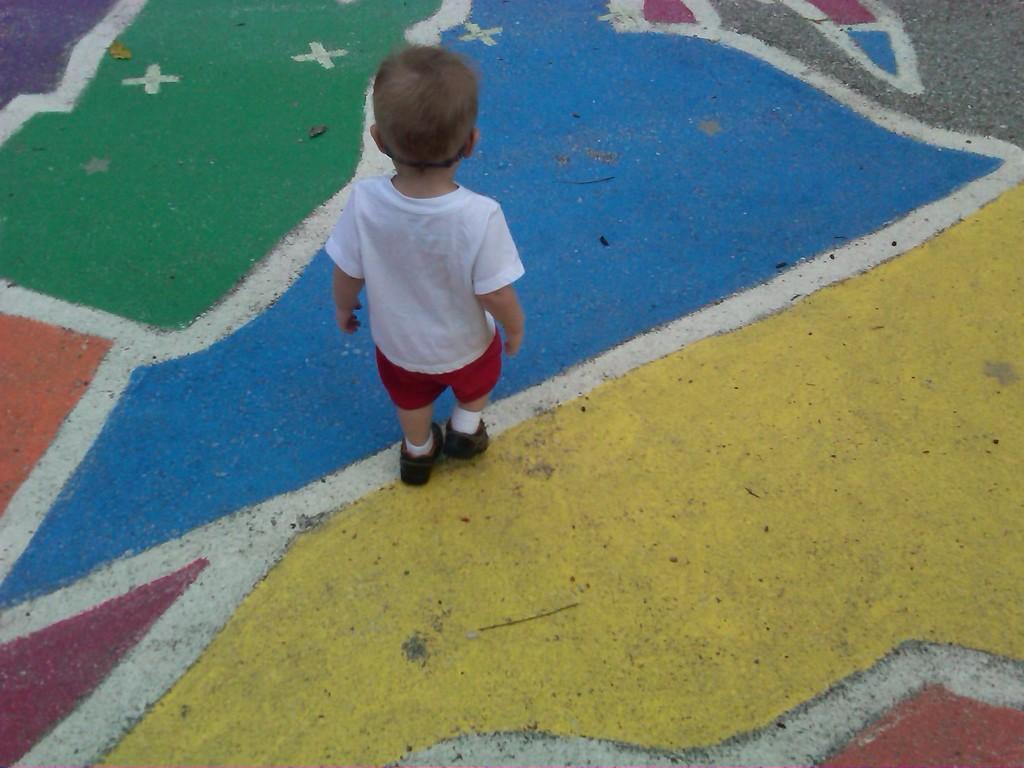In one or two sentences, can you explain what this image depicts? There is one kid standing on a colorful surface as we can see in the middle of this image. 